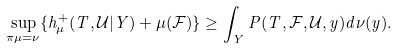Convert formula to latex. <formula><loc_0><loc_0><loc_500><loc_500>\sup _ { \pi \mu = \nu } \{ h ^ { + } _ { \mu } ( T , \mathcal { U } | Y ) + \mu ( \mathcal { F } ) \} \geq \int _ { Y } P ( T , \mathcal { F } , \mathcal { U } , y ) d \nu ( y ) .</formula> 